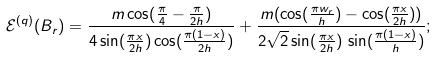Convert formula to latex. <formula><loc_0><loc_0><loc_500><loc_500>\mathcal { E } ^ { ( q ) } ( B _ { r } ) = \frac { m \cos ( \frac { \pi } { 4 } - \frac { \pi } { 2 h } ) } { 4 \sin ( \frac { \pi x } { 2 h } ) \cos ( \frac { \pi ( 1 - x ) } { 2 h } ) } + \frac { m ( \cos ( \frac { \pi w _ { r } } { h } ) - \cos ( \frac { \pi x } { 2 h } ) ) } { 2 \sqrt { 2 } \sin ( \frac { \pi x } { 2 h } ) \, \sin ( \frac { \pi ( 1 - x ) } { h } ) } ;</formula> 